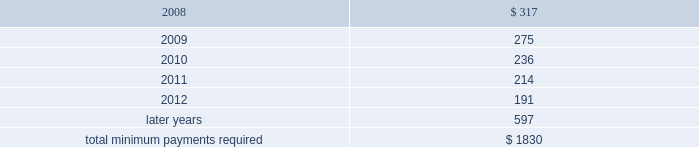Notes to consolidated financial statements at december 31 , 2007 , future minimum rental payments required under operating leases for continuing operations that have initial or remaining noncancelable lease terms in excess of one year , net of sublease rental income , most of which pertain to real estate leases , are as follows : ( millions ) .
Aon corporation .
Assuming that actual net rent expense will be the same as presented in the table , what would be the growth rate in the net rent expense from 2008 to 2009? 
Computations: ((275 - 317) / 317)
Answer: -0.13249. 